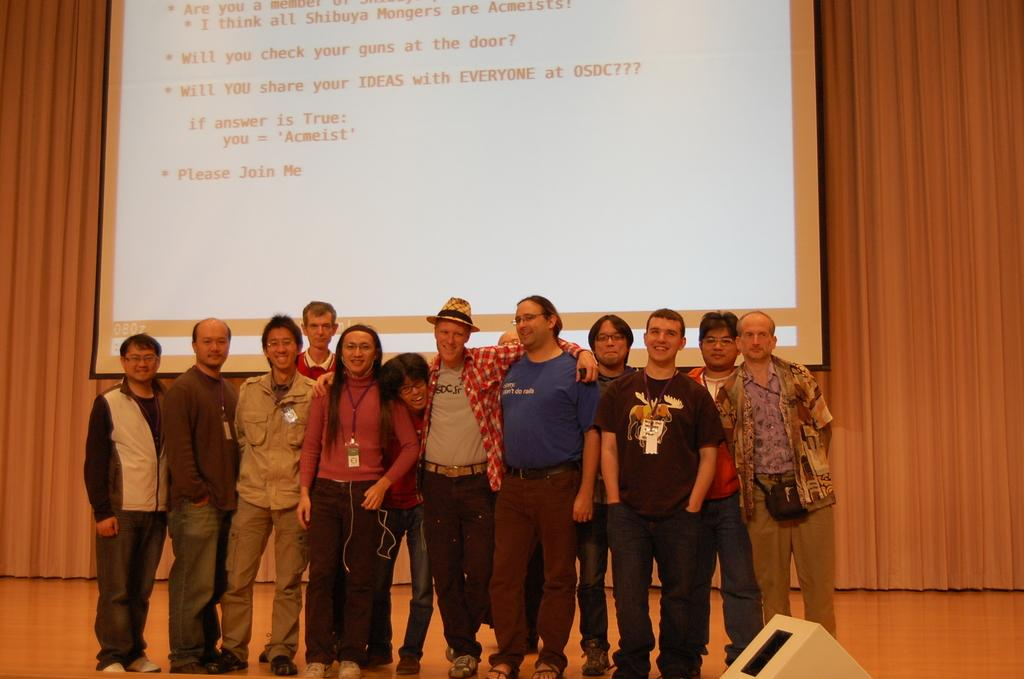How many people are in the image? There is a group of people in the image, but the exact number is not specified. Where are the people located in the image? The group of people is in the middle of the image. What can be seen in the background of the image? There is a projector screen in the background of the image. What type of art can be seen hanging on the walls in the image? There is no mention of any art or paintings hanging on the walls in the image. Can you tell me how many balls are present in the image? There is no mention of any balls in the image. 